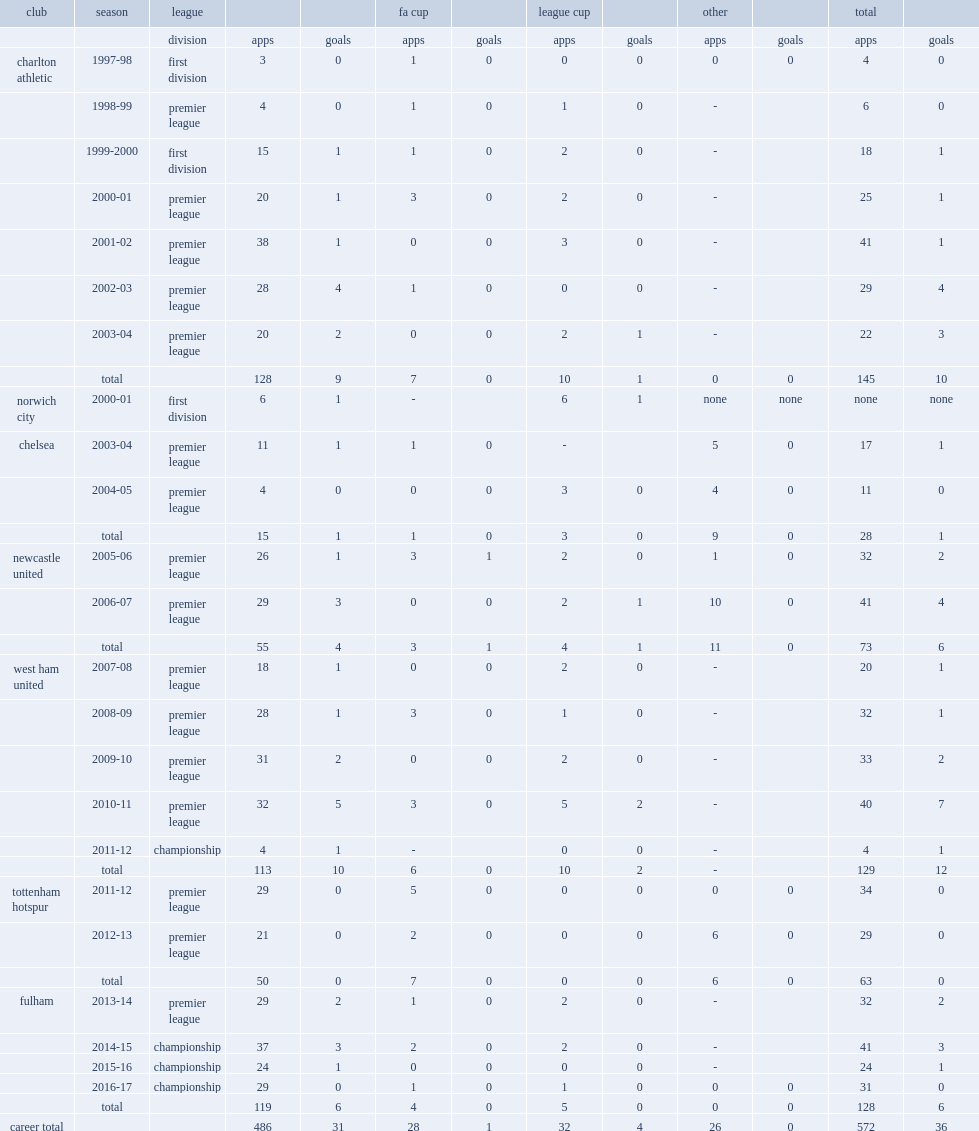How many league goals did parker score for west ham united in the championship in 2011-12? 1.0. 